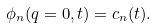<formula> <loc_0><loc_0><loc_500><loc_500>\phi _ { n } ( q = 0 , t ) = c _ { n } ( t ) .</formula> 